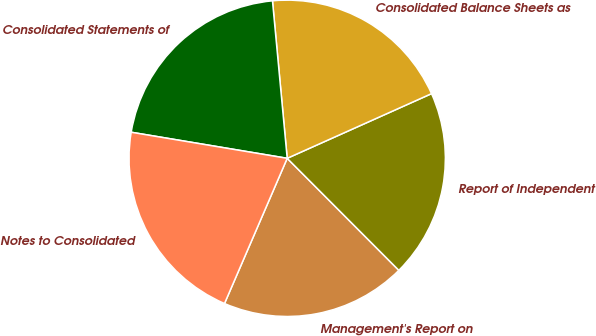Convert chart to OTSL. <chart><loc_0><loc_0><loc_500><loc_500><pie_chart><fcel>Management's Report on<fcel>Report of Independent<fcel>Consolidated Balance Sheets as<fcel>Consolidated Statements of<fcel>Notes to Consolidated<nl><fcel>18.96%<fcel>19.23%<fcel>19.78%<fcel>20.88%<fcel>21.15%<nl></chart> 